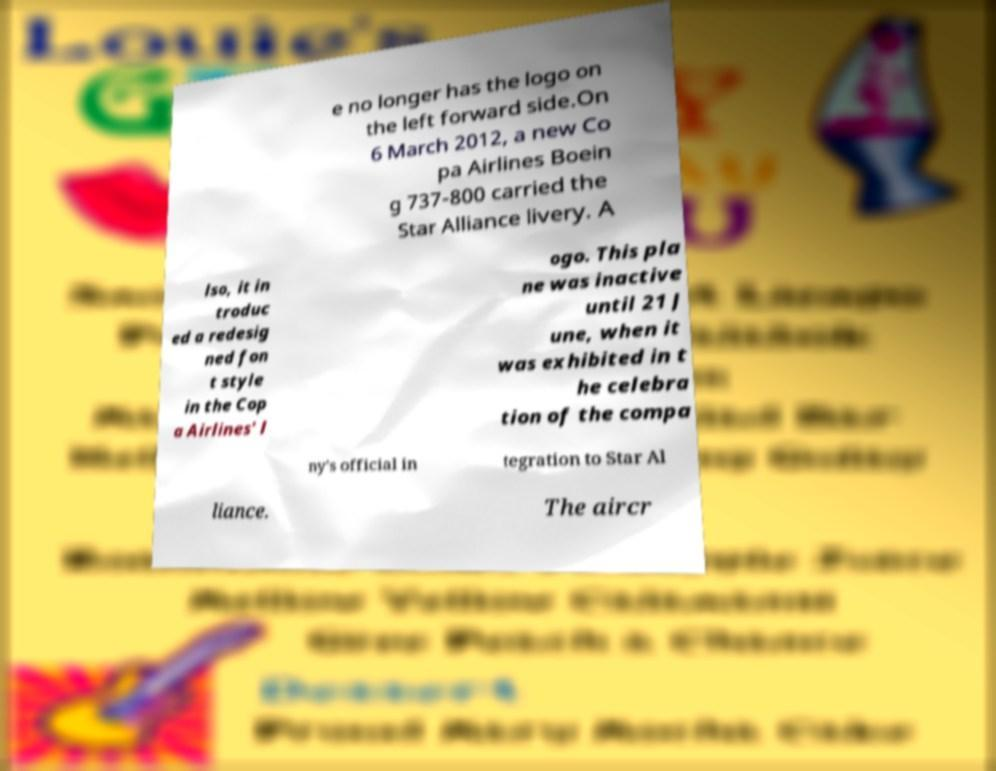Can you read and provide the text displayed in the image?This photo seems to have some interesting text. Can you extract and type it out for me? e no longer has the logo on the left forward side.On 6 March 2012, a new Co pa Airlines Boein g 737-800 carried the Star Alliance livery. A lso, it in troduc ed a redesig ned fon t style in the Cop a Airlines' l ogo. This pla ne was inactive until 21 J une, when it was exhibited in t he celebra tion of the compa ny's official in tegration to Star Al liance. The aircr 